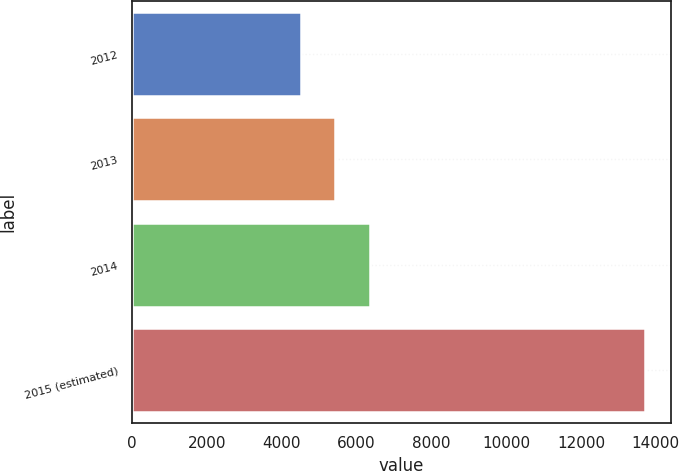Convert chart to OTSL. <chart><loc_0><loc_0><loc_500><loc_500><bar_chart><fcel>2012<fcel>2013<fcel>2014<fcel>2015 (estimated)<nl><fcel>4509<fcel>5429.9<fcel>6350.8<fcel>13718<nl></chart> 